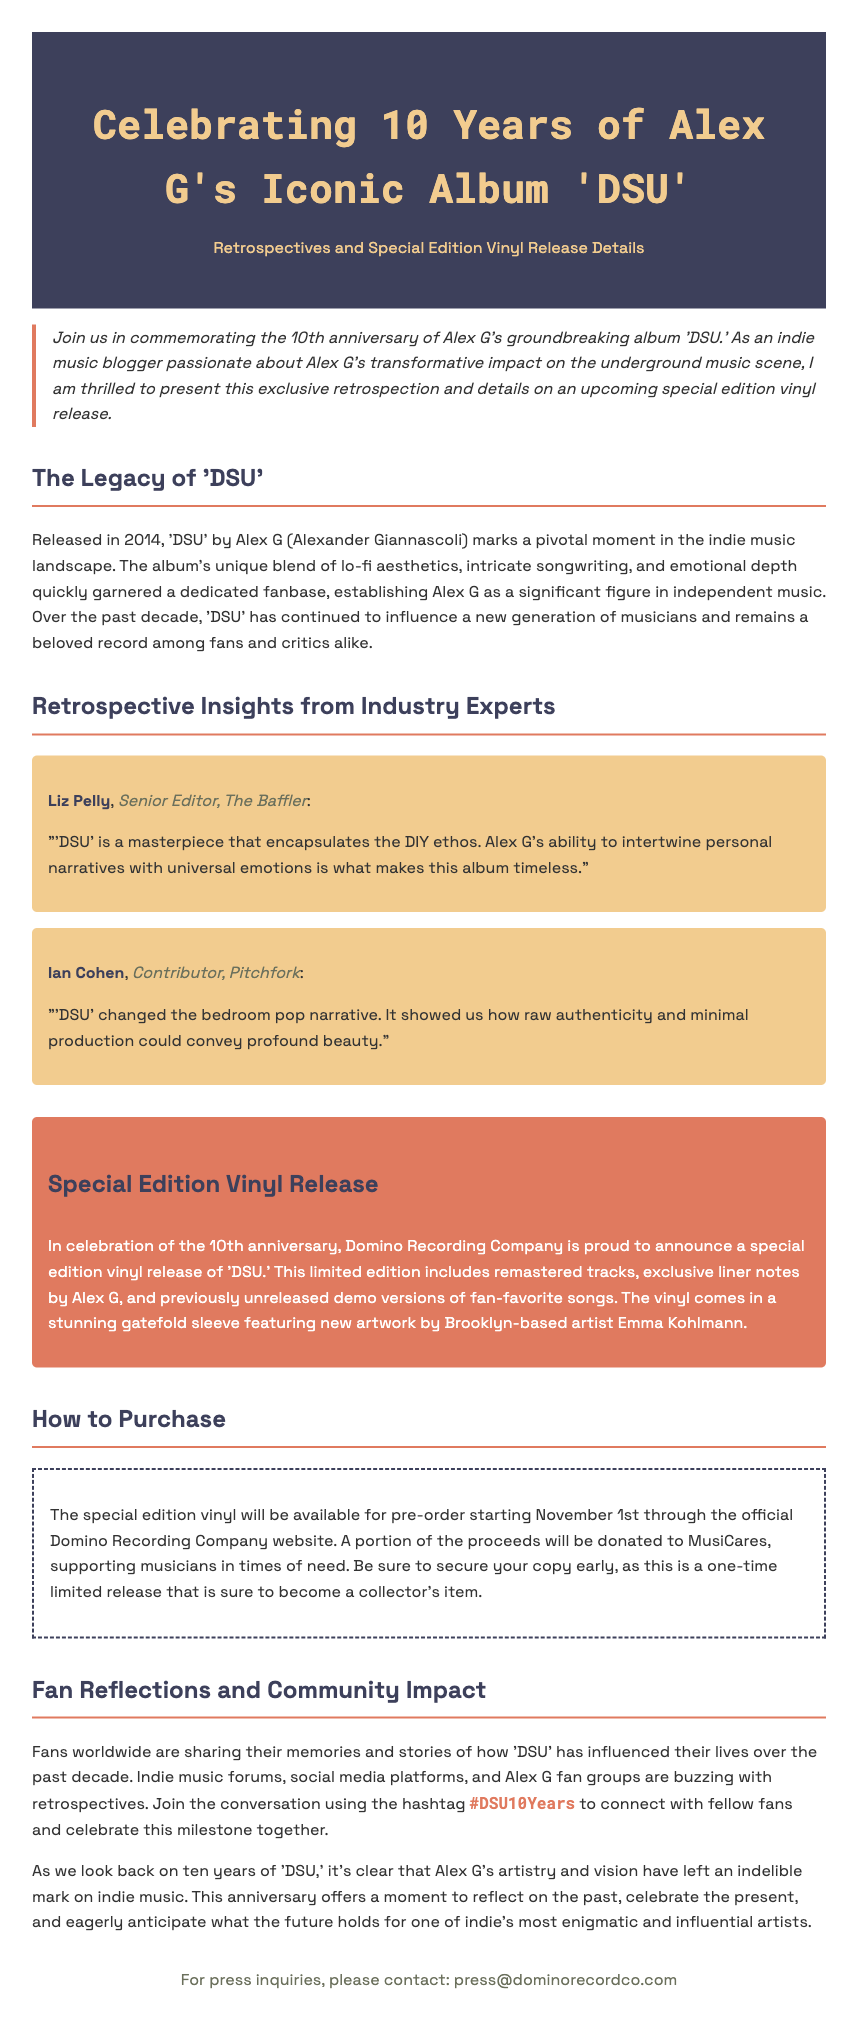What year was 'DSU' released? The document states that 'DSU' was released in 2014.
Answer: 2014 Who is the artist behind 'DSU'? The document references Alex G as the artist behind the album 'DSU'.
Answer: Alex G What is included in the special edition vinyl release? The document mentions remastered tracks, exclusive liner notes by Alex G, and unreleased demo versions.
Answer: Remastered tracks, exclusive liner notes, unreleased demo versions When will the special edition vinyl be available for pre-order? The document specifies that pre-orders will begin on November 1st.
Answer: November 1st Who provided insights in the retrospective section? Liz Pelly and Ian Cohen are the experts quoted in the retrospective section.
Answer: Liz Pelly and Ian Cohen What organization will receive a portion of the pre-order proceeds? The document states that a portion of the proceeds will be donated to MusiCares.
Answer: MusiCares What is the hashtag for fans to use when sharing their stories? The document encourages using the hashtag #DSU10Years for fan reflections.
Answer: #DSU10Years What type of artwork is featured on the vinyl sleeve? The document mentions that the new artwork is by Brooklyn-based artist Emma Kohlmann.
Answer: Emma Kohlmann 